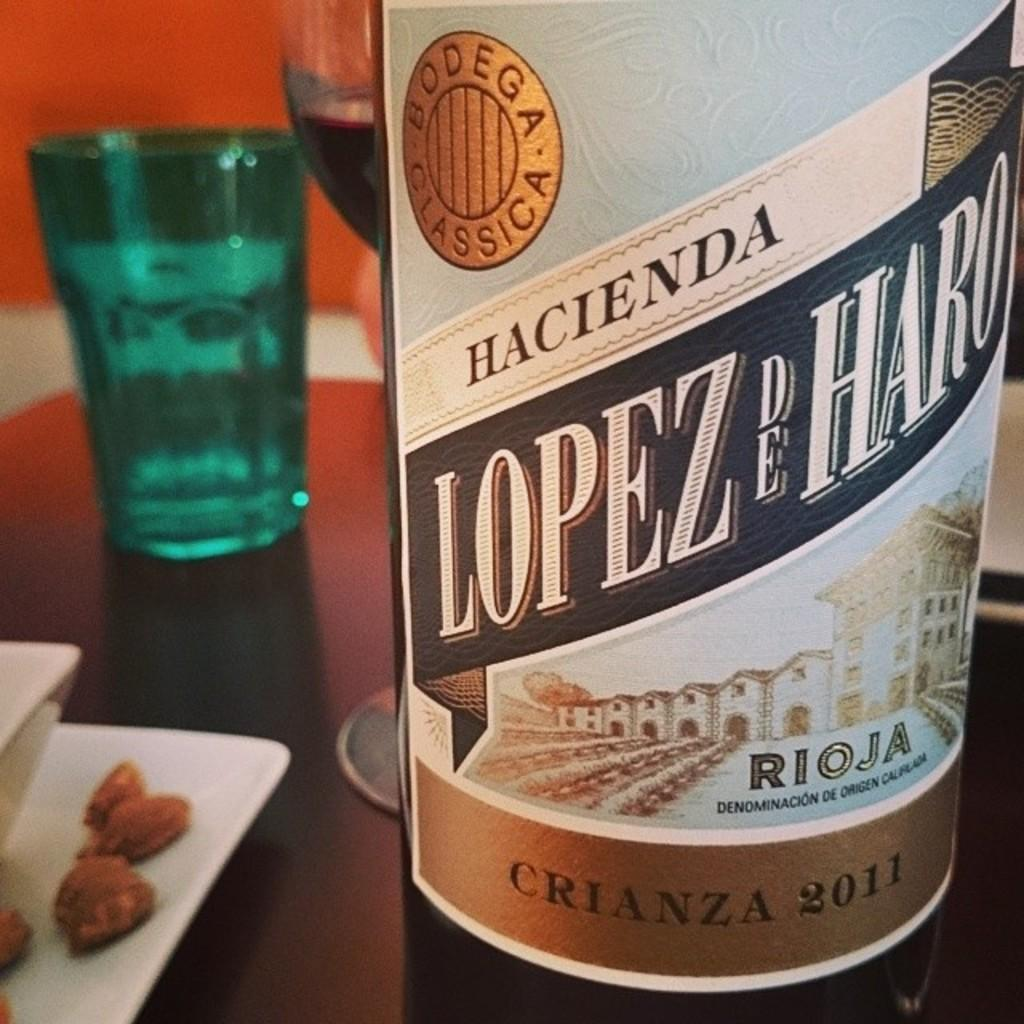<image>
Describe the image concisely. A bottle of Hacienda Lopez de Haro sits on a table. 